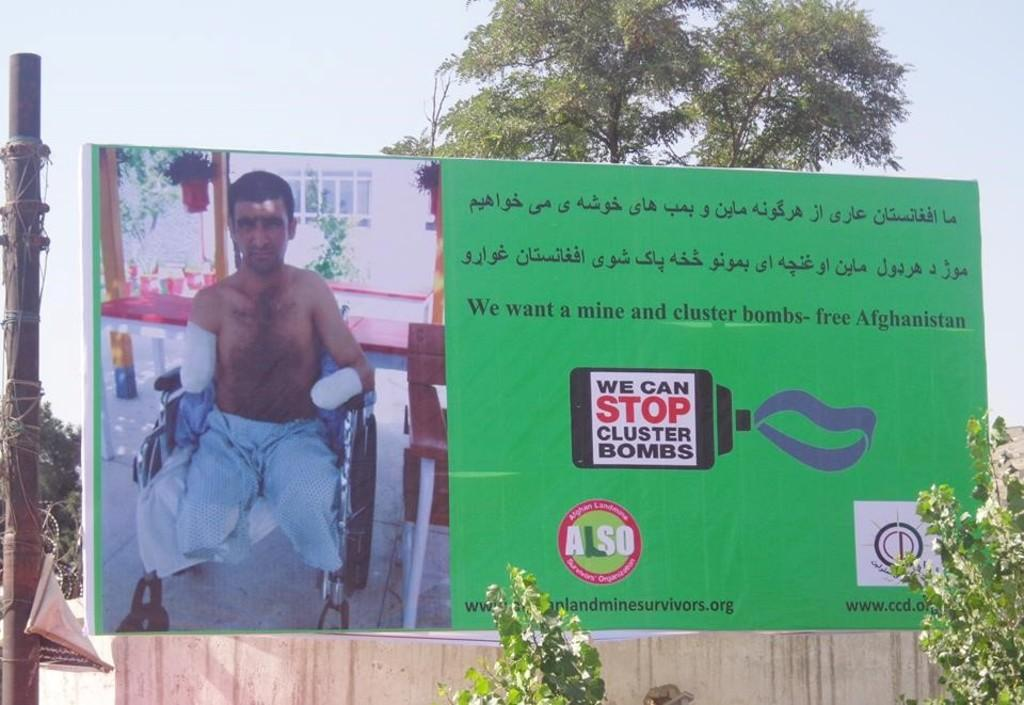What is featured on the poster in the image? The poster contains text and a picture. Can you describe the background of the image? There are trees, a pole, and a tree in the background of the image. The sky is also visible. What is the primary subject of the poster? The poster's primary subject cannot be determined from the provided facts. How many pickles are hanging from the tree in the image? There are no pickles present in the image; it features a poster with text and a picture, as well as a background with trees, a pole, and the sky. Can you describe the sound of the person sneezing in the image? There is no person sneezing in the image; it features a poster with text and a picture, as well as a background with trees, a pole, and the sky. 